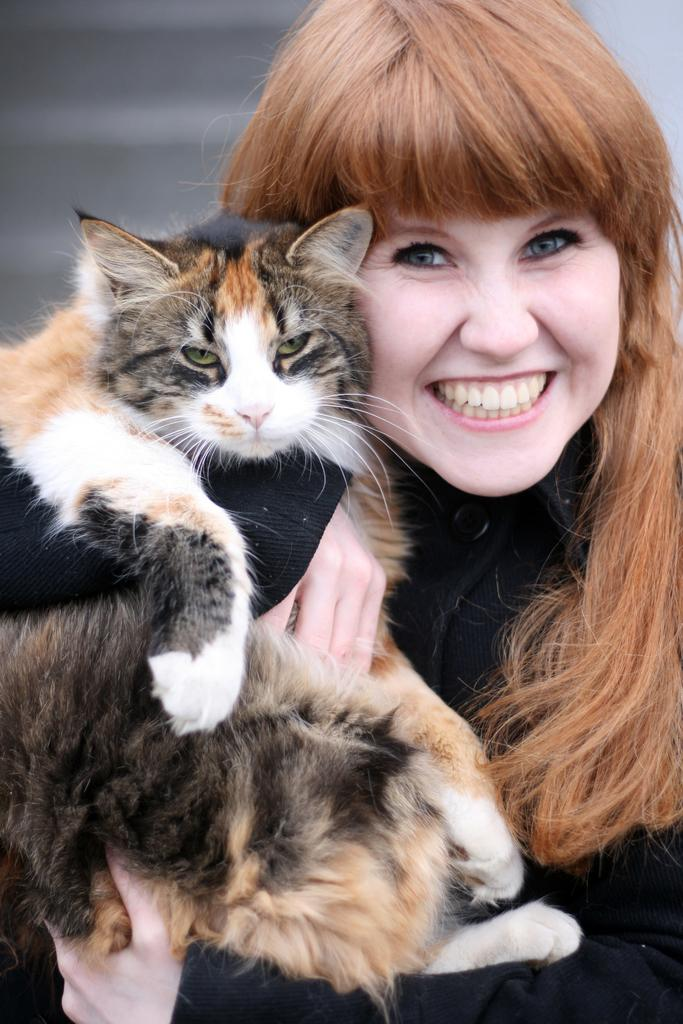Who is the main subject in the picture? There is a woman in the picture. What is the woman holding in the picture? The woman is holding a cat. Where is the cat located in relation to the woman? The cat is in her hands. What expression does the woman have the woman have in the picture? The woman is smiling. What type of worm can be seen crawling on the woman's shoulder in the image? There is no worm present on the woman's shoulder in the image. 